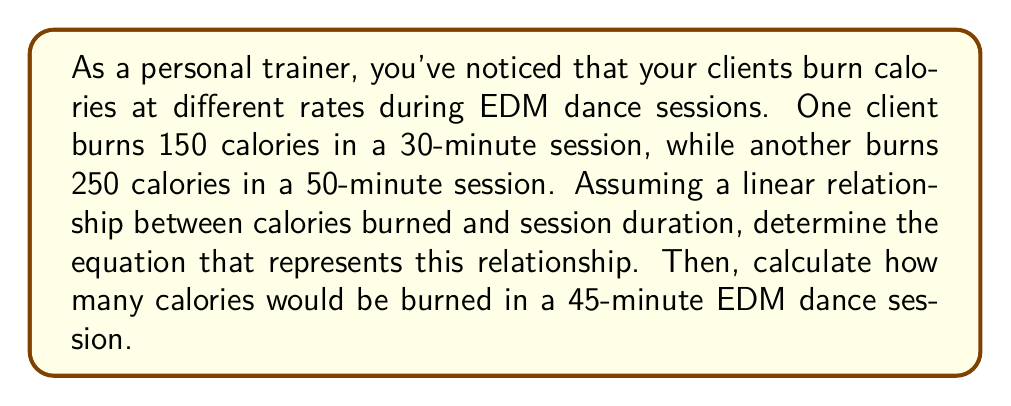Help me with this question. Let's approach this step-by-step:

1) Let $x$ represent the session duration in minutes and $y$ represent the calories burned.

2) We have two points: (30, 150) and (50, 250)

3) To find the linear equation, we'll use the point-slope form: $y - y_1 = m(x - x_1)$

4) First, calculate the slope $m$:
   $$m = \frac{y_2 - y_1}{x_2 - x_1} = \frac{250 - 150}{50 - 30} = \frac{100}{20} = 5$$

5) Now we can use either point to create our equation. Let's use (30, 150):
   $$y - 150 = 5(x - 30)$$

6) Simplify:
   $$y = 5x - 150 + 150$$
   $$y = 5x$$

7) This is our linear equation: $y = 5x$

8) To find calories burned in a 45-minute session, substitute $x = 45$:
   $$y = 5(45) = 225$$

Therefore, in a 45-minute EDM dance session, 225 calories would be burned.
Answer: $y = 5x$; 225 calories 